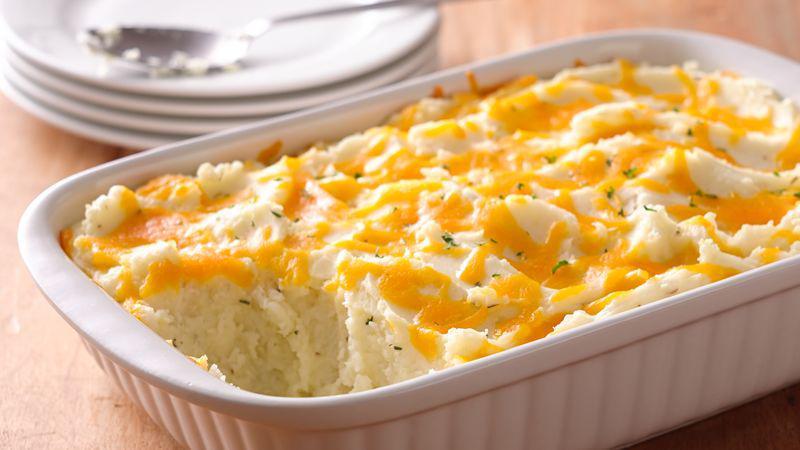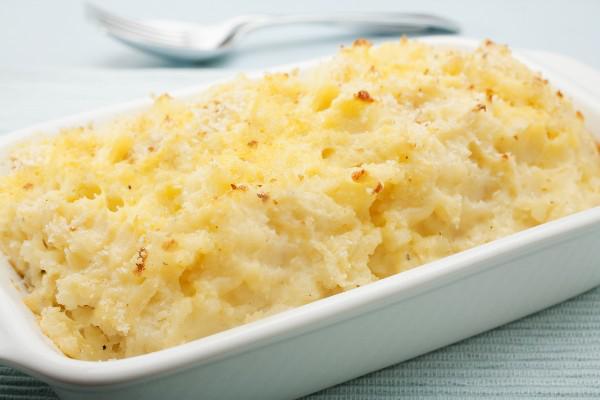The first image is the image on the left, the second image is the image on the right. Examine the images to the left and right. Is the description "There are sppons near mashed potatoes." accurate? Answer yes or no. Yes. 